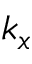Convert formula to latex. <formula><loc_0><loc_0><loc_500><loc_500>k _ { x }</formula> 